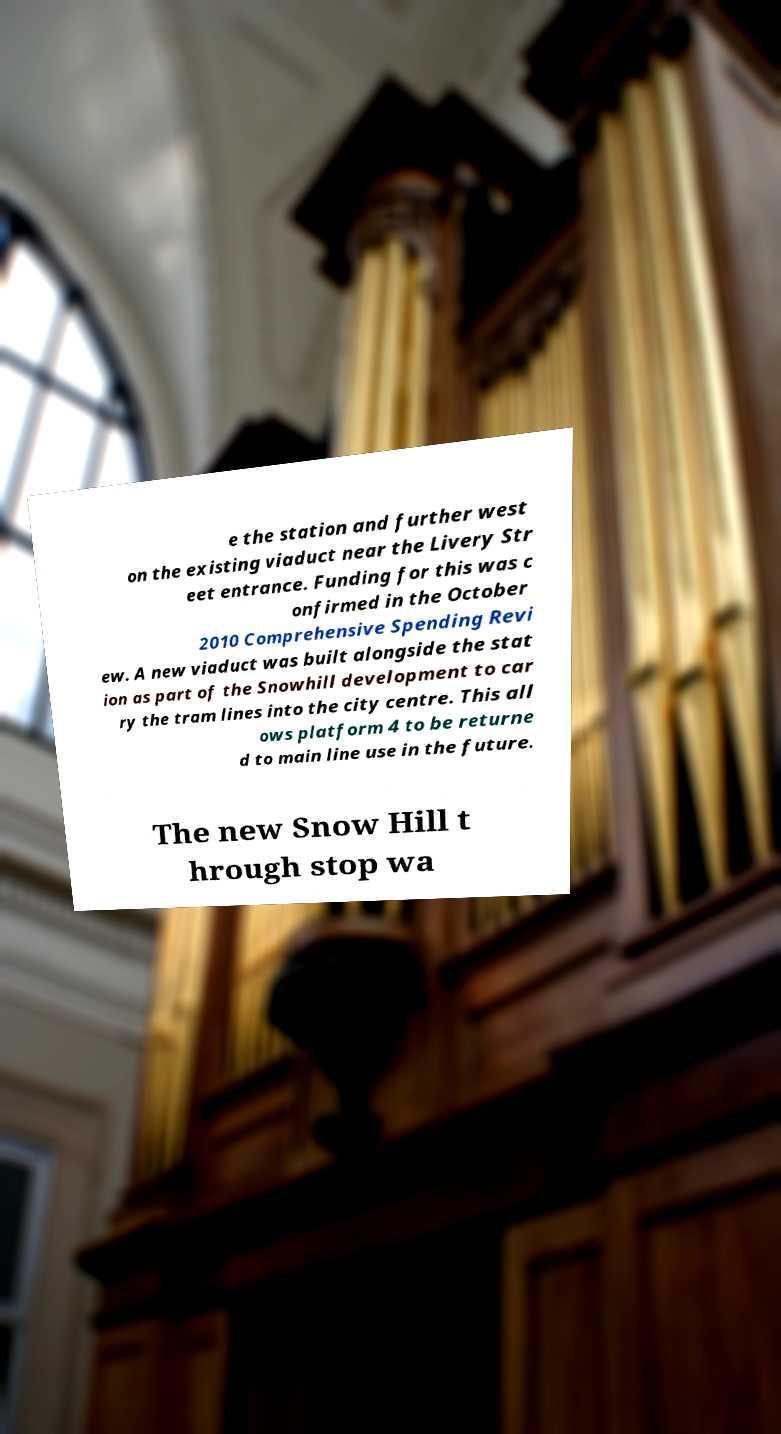For documentation purposes, I need the text within this image transcribed. Could you provide that? e the station and further west on the existing viaduct near the Livery Str eet entrance. Funding for this was c onfirmed in the October 2010 Comprehensive Spending Revi ew. A new viaduct was built alongside the stat ion as part of the Snowhill development to car ry the tram lines into the city centre. This all ows platform 4 to be returne d to main line use in the future. The new Snow Hill t hrough stop wa 